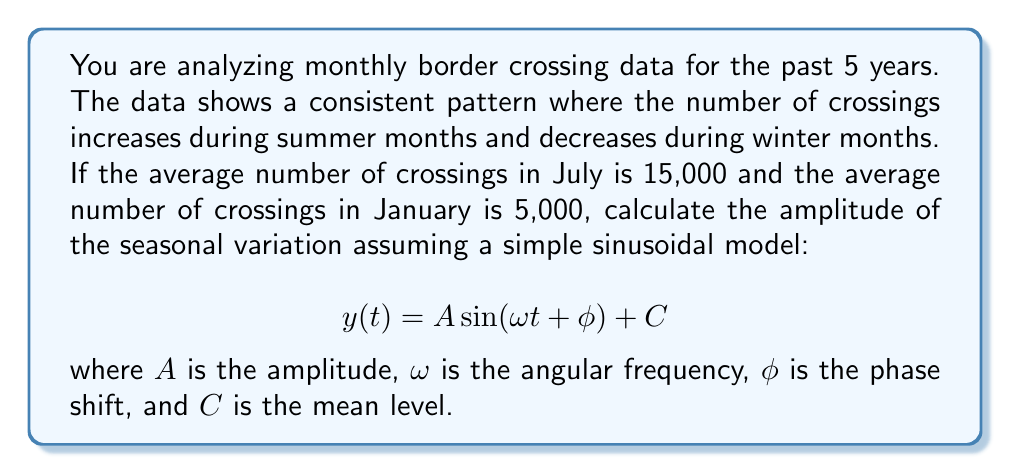Can you answer this question? To solve this problem, we need to understand that the amplitude in a sinusoidal model represents half the difference between the maximum and minimum values. In this case, July represents the peak (maximum) and January represents the trough (minimum) of the seasonal pattern.

1. Identify the maximum and minimum values:
   Max (July average): 15,000
   Min (January average): 5,000

2. Calculate the difference between max and min:
   $15,000 - 5,000 = 10,000$

3. The amplitude is half of this difference:
   $A = \frac{10,000}{2} = 5,000$

In the sinusoidal model $y(t) = A \sin(\omega t + \phi) + C$:
- $A = 5,000$ (calculated amplitude)
- $\omega = \frac{2\pi}{12}$ (assuming monthly data, so the period is 12 months)
- $\phi$ would depend on which month is set as $t=0$
- $C = \frac{15,000 + 5,000}{2} = 10,000$ (the mean level)

Therefore, the seasonal pattern can be approximated by:

$$ y(t) = 5,000 \sin(\frac{2\pi}{12}t + \phi) + 10,000 $$

This model captures the seasonal variation with an amplitude of 5,000 around a mean level of 10,000 border crossings per month.
Answer: The amplitude of the seasonal variation is 5,000 border crossings. 